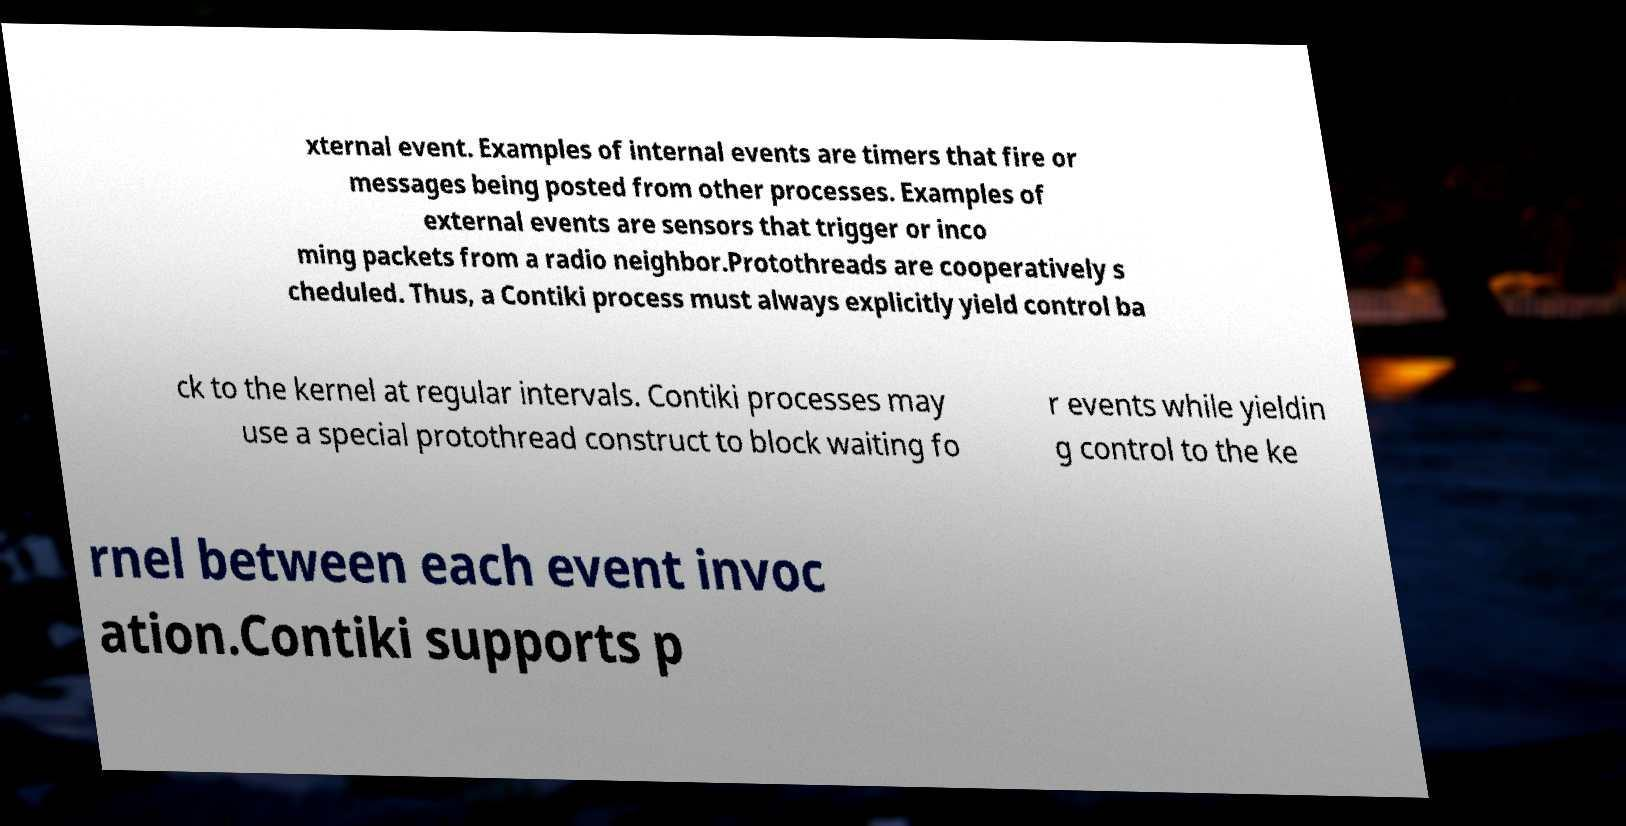Can you read and provide the text displayed in the image?This photo seems to have some interesting text. Can you extract and type it out for me? xternal event. Examples of internal events are timers that fire or messages being posted from other processes. Examples of external events are sensors that trigger or inco ming packets from a radio neighbor.Protothreads are cooperatively s cheduled. Thus, a Contiki process must always explicitly yield control ba ck to the kernel at regular intervals. Contiki processes may use a special protothread construct to block waiting fo r events while yieldin g control to the ke rnel between each event invoc ation.Contiki supports p 